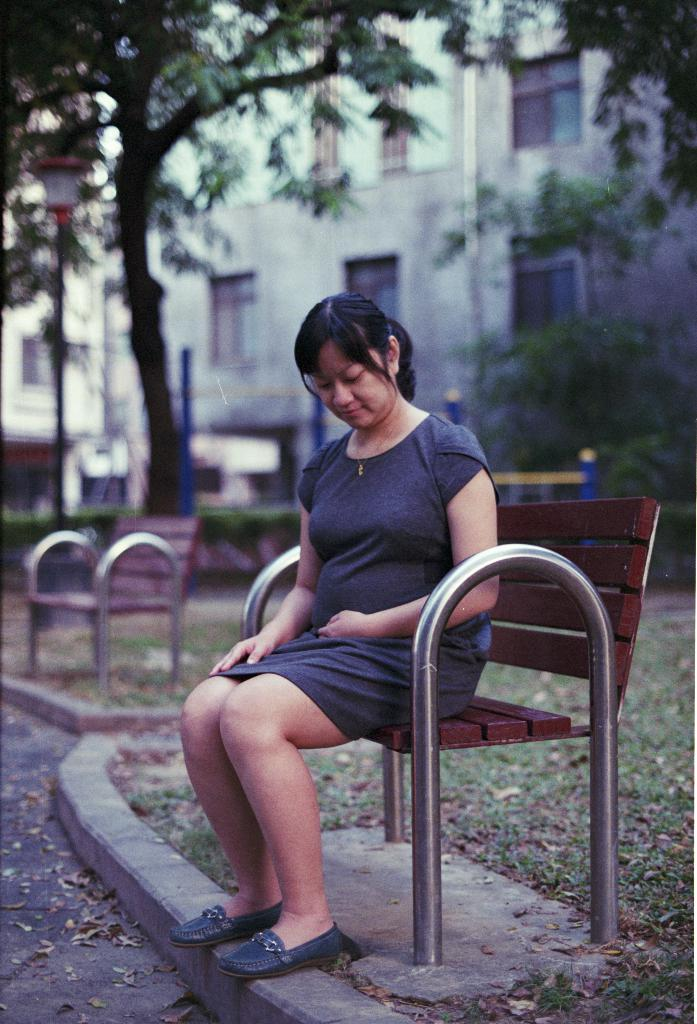What type of seating is visible in the image? There are benches in the image. Who is sitting on one of the benches? A lady is sitting on one of the benches. What is on the ground in the image? There is grass on the ground. What can be seen in the background of the image? There are trees and a building with windows in the background of the image. How many horses are present in the image? There are no horses present in the image. What type of animal is saying good-bye to the lady on the bench? There is no animal present in the image, let alone one saying good-bye. 